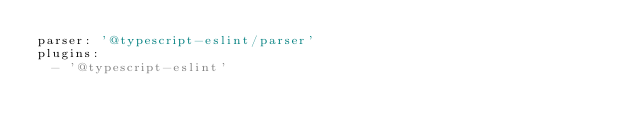<code> <loc_0><loc_0><loc_500><loc_500><_YAML_>parser: '@typescript-eslint/parser'
plugins:
  - '@typescript-eslint'</code> 